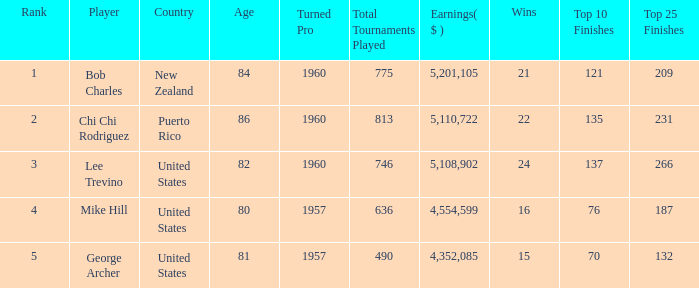On average, how many wins have a rank lower than 1? None. 